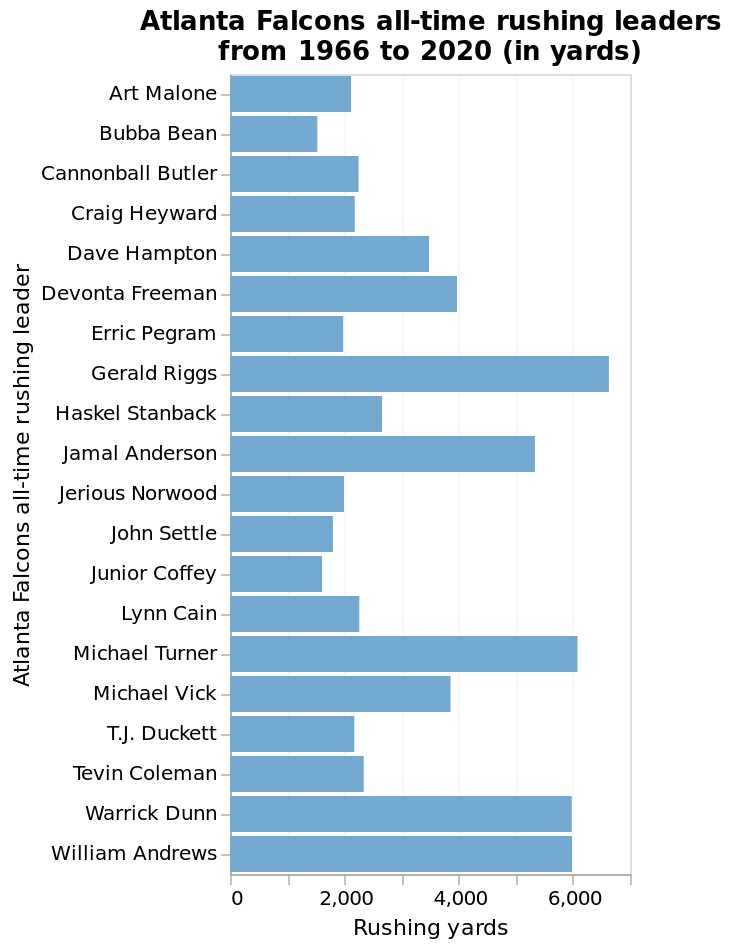<image>
What does the y-axis represent on the bar chart? The y-axis on the bar chart represents the Atlanta Falcons all-time rushing leaders in a categorical scale. please enumerates aspects of the construction of the chart Here a bar chart is called Atlanta Falcons all-time rushing leaders from 1966 to 2020 (in yards). The x-axis shows Rushing yards using linear scale of range 0 to 7,000 while the y-axis measures Atlanta Falcons all-time rushing leader as categorical scale starting with Art Malone and ending with William Andrews. How many yards do the majority of the players have?  Under 3000 yards Who is the last Atlanta Falcons all-time rushing leader?  The last Atlanta Falcons all-time rushing leader is William Andrews. How many yards do Warrick Dunn and William Andrews have in total?  6000 yards Offer a thorough analysis of the image. Warrick Dunn and William Andrews are equal with 6000, the majority of them have under 3000, Gerard Riggs has had the most. How many years does the bar chart cover? The bar chart covers the years from 1966 to 2020. 